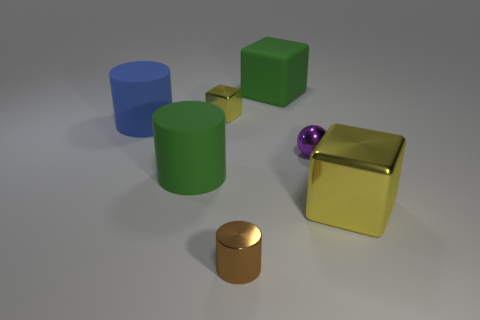Is there anything else that has the same shape as the purple metallic thing?
Keep it short and to the point. No. What number of other things are there of the same color as the tiny block?
Keep it short and to the point. 1. There is a tiny thing that is on the left side of the cylinder on the right side of the big green object left of the tiny brown thing; what is its color?
Ensure brevity in your answer.  Yellow. Is the number of yellow metallic blocks that are behind the small metallic ball the same as the number of small brown shiny objects?
Your answer should be compact. Yes. There is a shiny block right of the brown cylinder; is its size the same as the big green rubber block?
Your response must be concise. Yes. What number of blue things are there?
Provide a succinct answer. 1. What number of things are both behind the large yellow thing and left of the tiny purple thing?
Give a very brief answer. 4. Are there any other small blocks made of the same material as the small yellow cube?
Your response must be concise. No. What is the material of the block that is in front of the rubber thing that is in front of the small purple metallic thing?
Provide a short and direct response. Metal. Is the number of purple metal things that are on the left side of the tiny purple ball the same as the number of things that are behind the tiny brown object?
Give a very brief answer. No. 